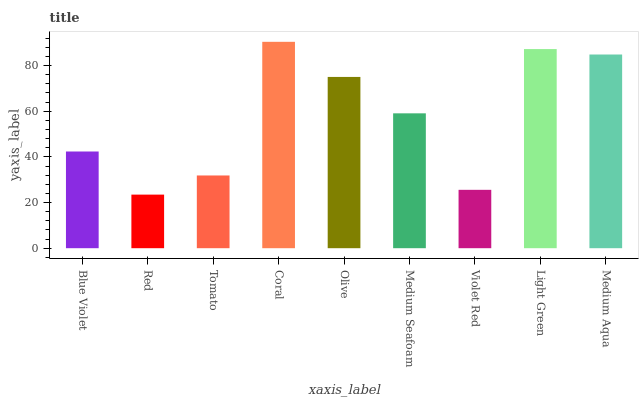Is Red the minimum?
Answer yes or no. Yes. Is Coral the maximum?
Answer yes or no. Yes. Is Tomato the minimum?
Answer yes or no. No. Is Tomato the maximum?
Answer yes or no. No. Is Tomato greater than Red?
Answer yes or no. Yes. Is Red less than Tomato?
Answer yes or no. Yes. Is Red greater than Tomato?
Answer yes or no. No. Is Tomato less than Red?
Answer yes or no. No. Is Medium Seafoam the high median?
Answer yes or no. Yes. Is Medium Seafoam the low median?
Answer yes or no. Yes. Is Red the high median?
Answer yes or no. No. Is Coral the low median?
Answer yes or no. No. 